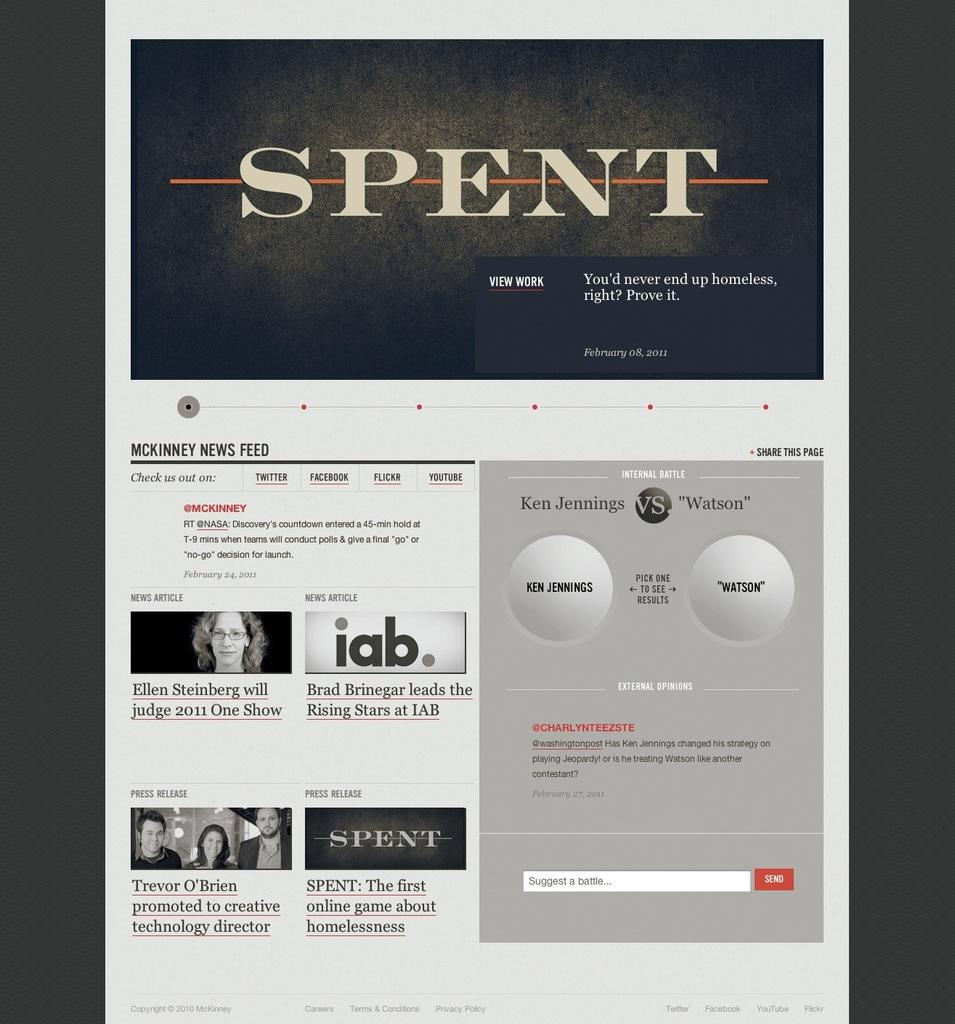<image>
Present a compact description of the photo's key features. Screenshot of a website for the game Spent. 